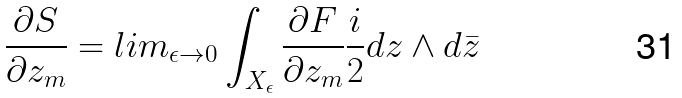Convert formula to latex. <formula><loc_0><loc_0><loc_500><loc_500>\frac { \partial S } { \partial z _ { m } } = l i m _ { \epsilon \rightarrow 0 } \int _ { X _ { \epsilon } } \frac { \partial F } { \partial z _ { m } } \frac { i } { 2 } d z \wedge d \bar { z }</formula> 